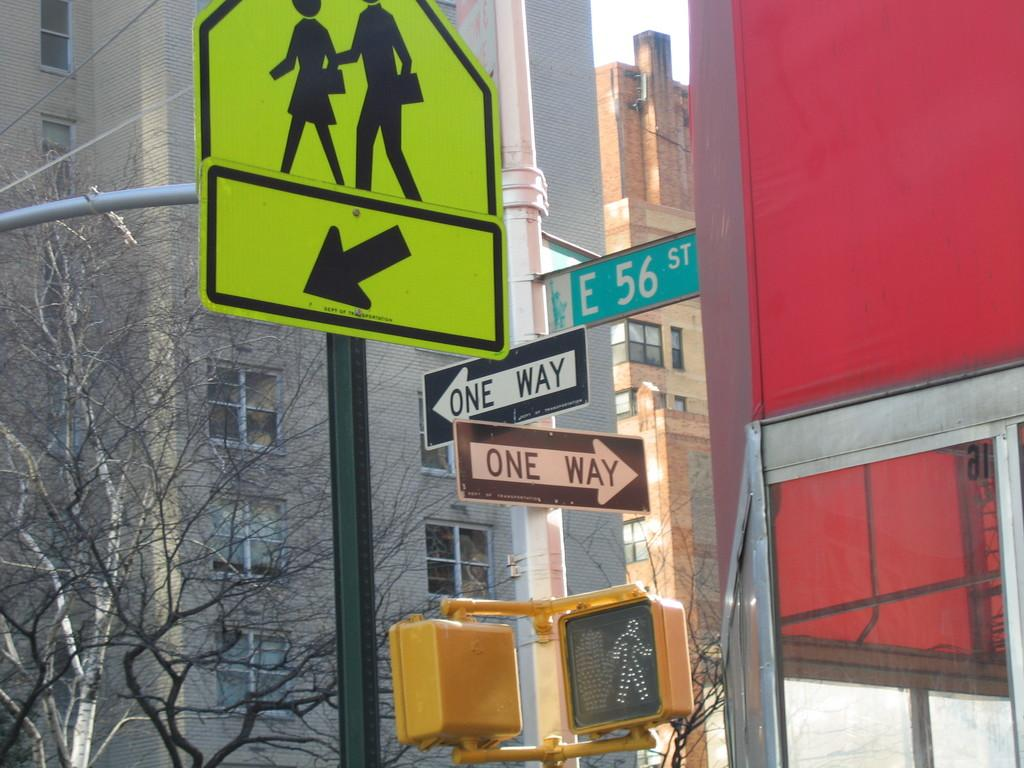<image>
Relay a brief, clear account of the picture shown. A pole has two one-way signs as well as a street sign for E 56 st. 